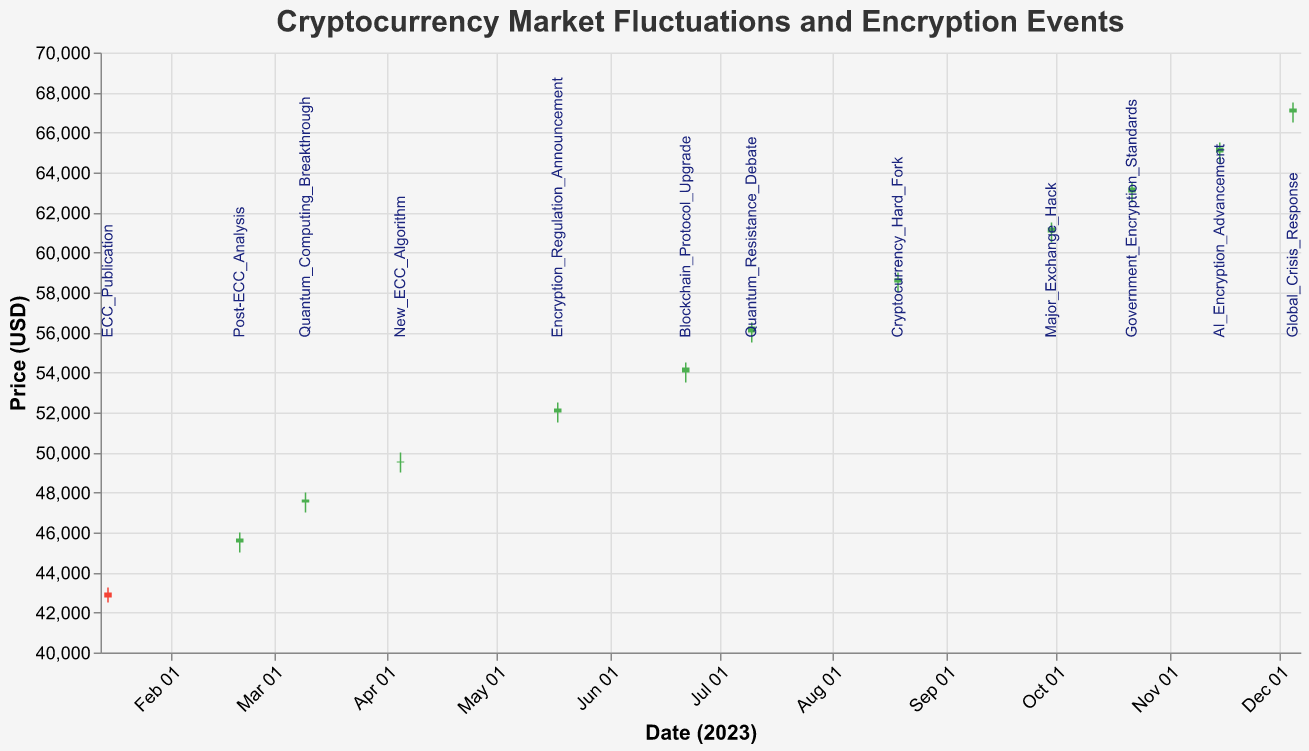What is the title of the figure? The title is generally located at the top of the figure and provides an overview of the content. Here, "Cryptocurrency Market Fluctuations and Encryption Events" is clearly stated.
Answer: Cryptocurrency Market Fluctuations and Encryption Events How many data points represent the cryptocurrency prices throughout the year? Each candlestick represents a data point with specific dates shown along the x-axis. Counting all the provided dates (from January to December) gives 12 data points.
Answer: 12 What is the significance of the text labels next to each candlestick? Each label next to a candlestick corresponds to a specific encryption-related event that occurred on that date. These events help in correlating market fluctuations with external news.
Answer: They indicate encryption-related events How does the price generally trend from January to December? Observing the candlestick plot from January (about $43,000) to December (about $67,000), the overall trend is upward, indicating a general increase in cryptocurrency prices over the year.
Answer: Upward Which event coincides with the highest closing price in 2023? The figure shows that the highest closing price is around early December, which is associated with the "Global Crisis Response" event.
Answer: Global Crisis Response Is there a pattern in volume traded throughout the year in relation to price movements? The volume traded increases steadily as the year progresses, in conjunction with the rising prices, indicating higher market activity and interest over time.
Answer: Increasing volume with increasing prices Which two time points have the highest and lowest volatility (difference between high and low prices)? January 15 and December 5 both demonstrate volatility. By examining candlestick lengths, January 15 has the widest range (high of $43,250 and low of $42,500, a difference of $750), while a more stable month like mid-year, for example, June 22 (high of $54,500 and low of $53,500, a difference of $1,000) can be used for comparison.
Answer: January 15 and June 22 Compare the price change significance between "Quantum Computing Breakthrough" and "New ECC Algorithm". Look at the candles for March 10 and April 5. For March 10 (Quantum Computing Breakthrough): Open at $47,500 and close at $47,650. Change: $150. For April 5 (New ECC Algorithm): Open at $49,500 and close at $49,550. Change: $50. Thus, the price change is more significant during "Quantum Computing Breakthrough".
Answer: More significant during Quantum Computing Breakthrough How does the market react to the "Major Exchange Hack" event on September 30? The candlestick for September 30 shows slight volatility with high at $61,500 and low at $60,500, closing at $61,250. Despite the hack, the market closes higher than the opening price, indicating resilience or unaffected sentiment.
Answer: Resilient or unaffected What is the lowest closing price recorded and which event does it correspond to? The lowest closing price can be identified by looking at the shortest red bar among all the candlesticks. This belongs to January 15th at $42,750, corresponding to the "ECC Publication" event.
Answer: $42,750, ECC Publication 